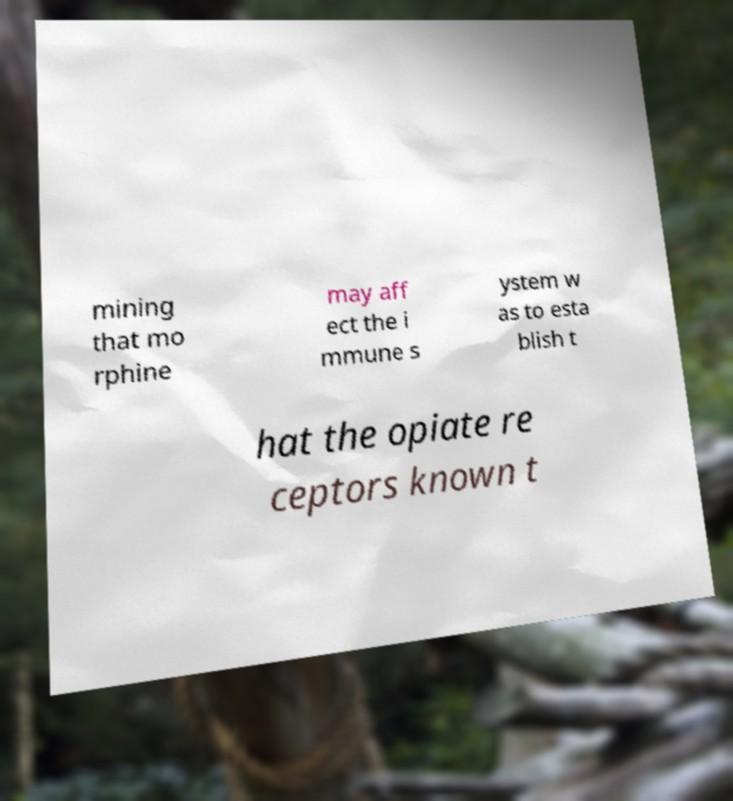Could you assist in decoding the text presented in this image and type it out clearly? mining that mo rphine may aff ect the i mmune s ystem w as to esta blish t hat the opiate re ceptors known t 